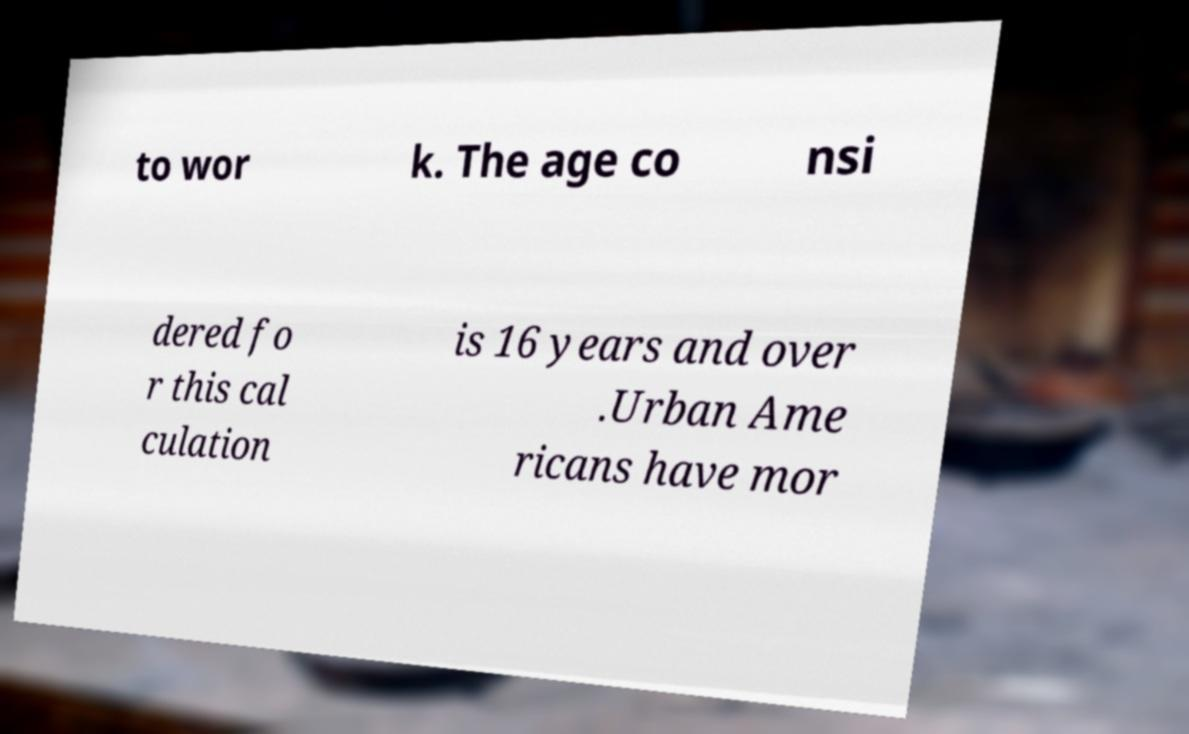Could you assist in decoding the text presented in this image and type it out clearly? to wor k. The age co nsi dered fo r this cal culation is 16 years and over .Urban Ame ricans have mor 